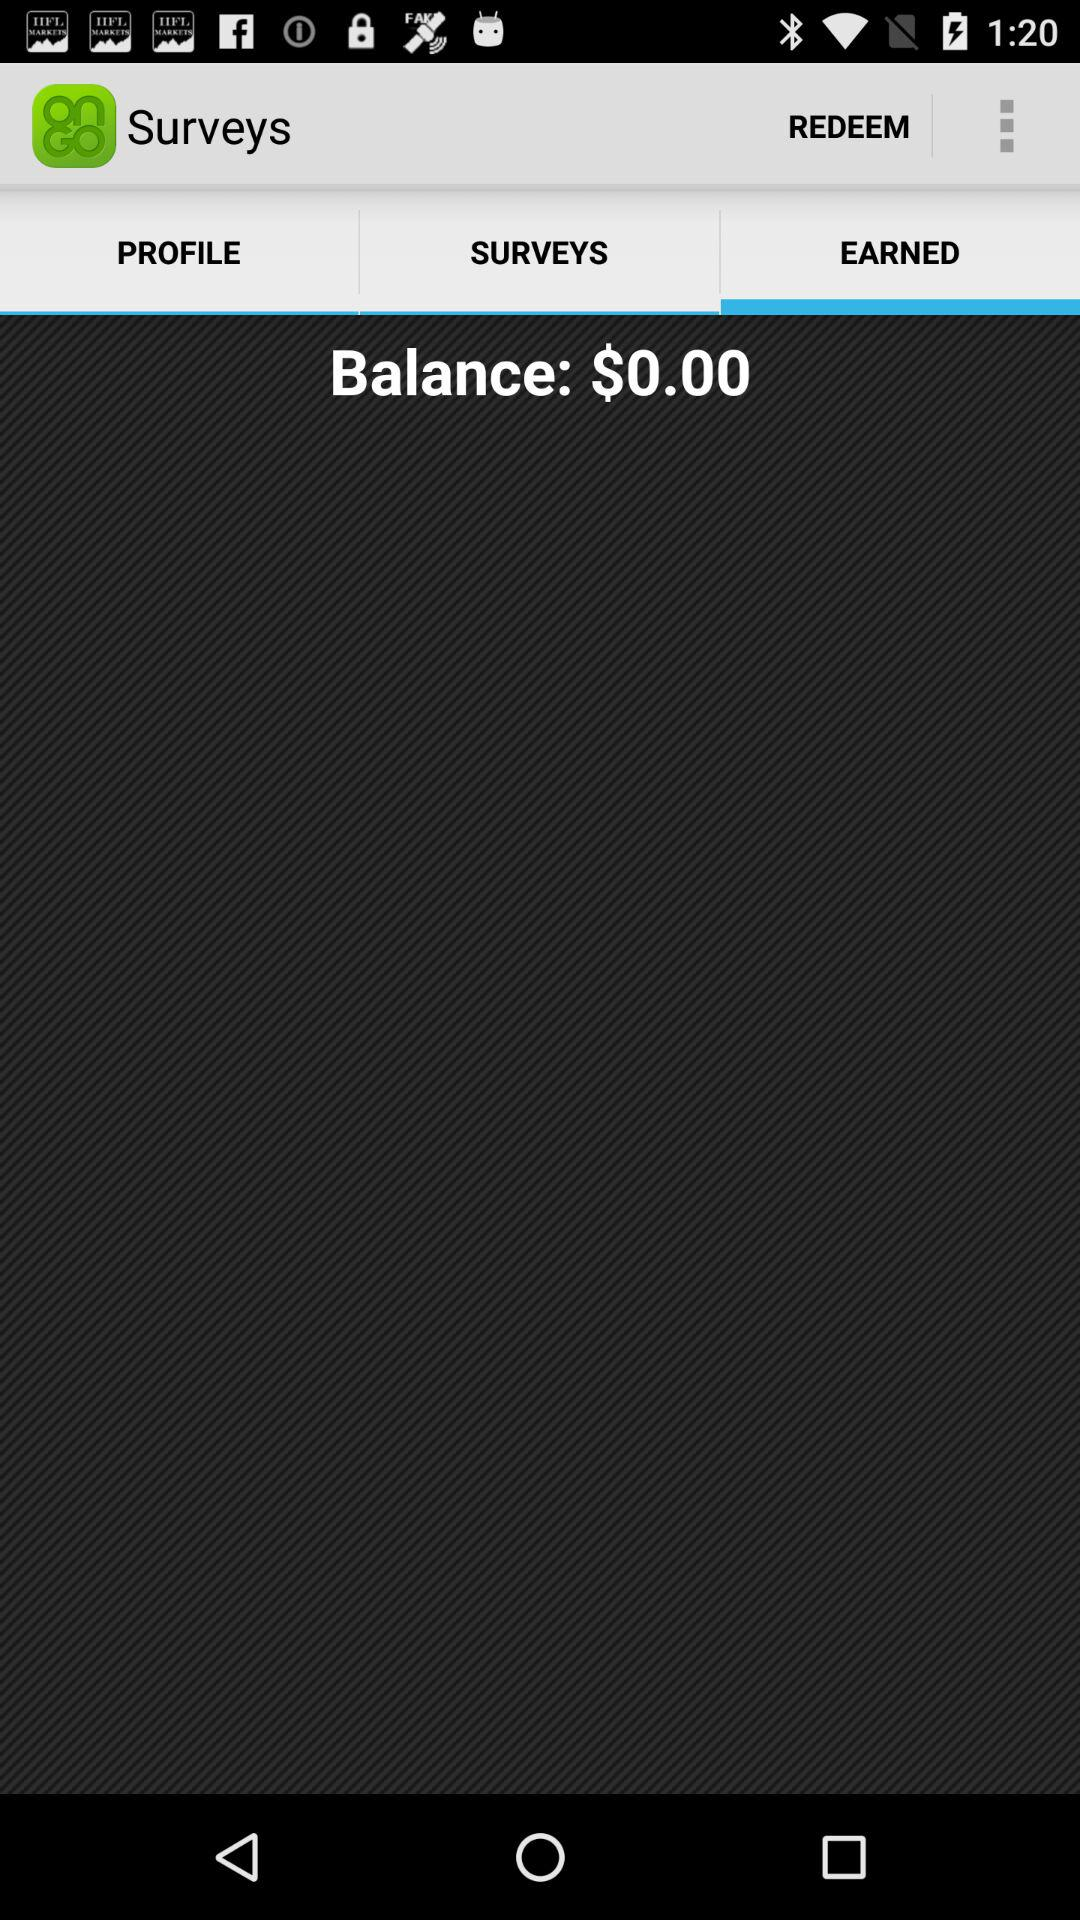Which option is selected in surveys tab? The selected option is Earned. 